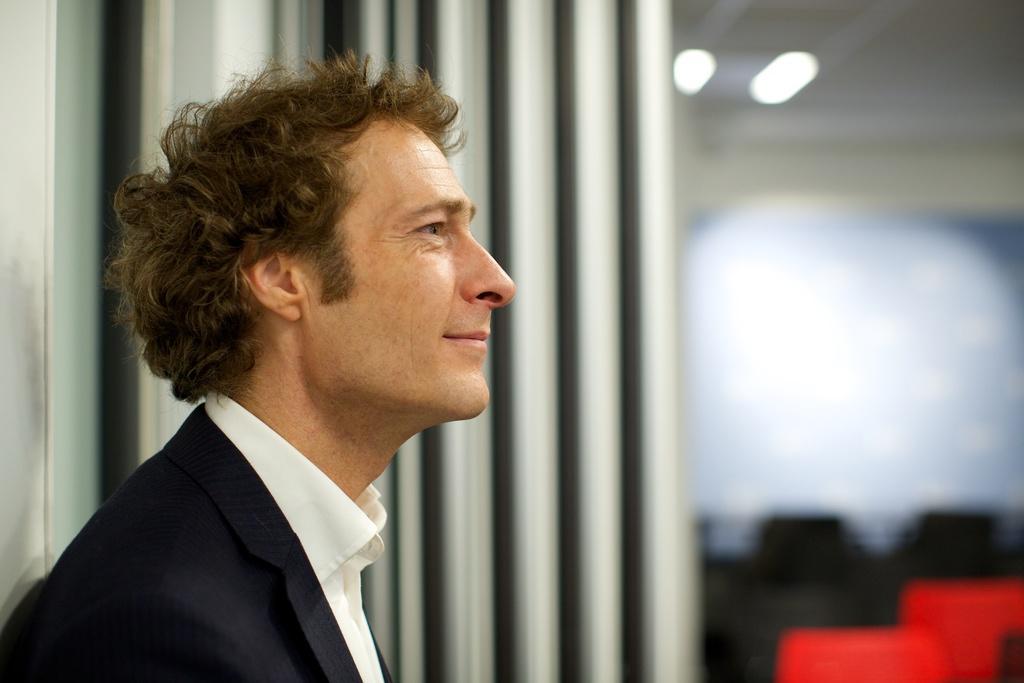Please provide a concise description of this image. In this image I can see a person standing and facing towards the right. The background is blurred. 